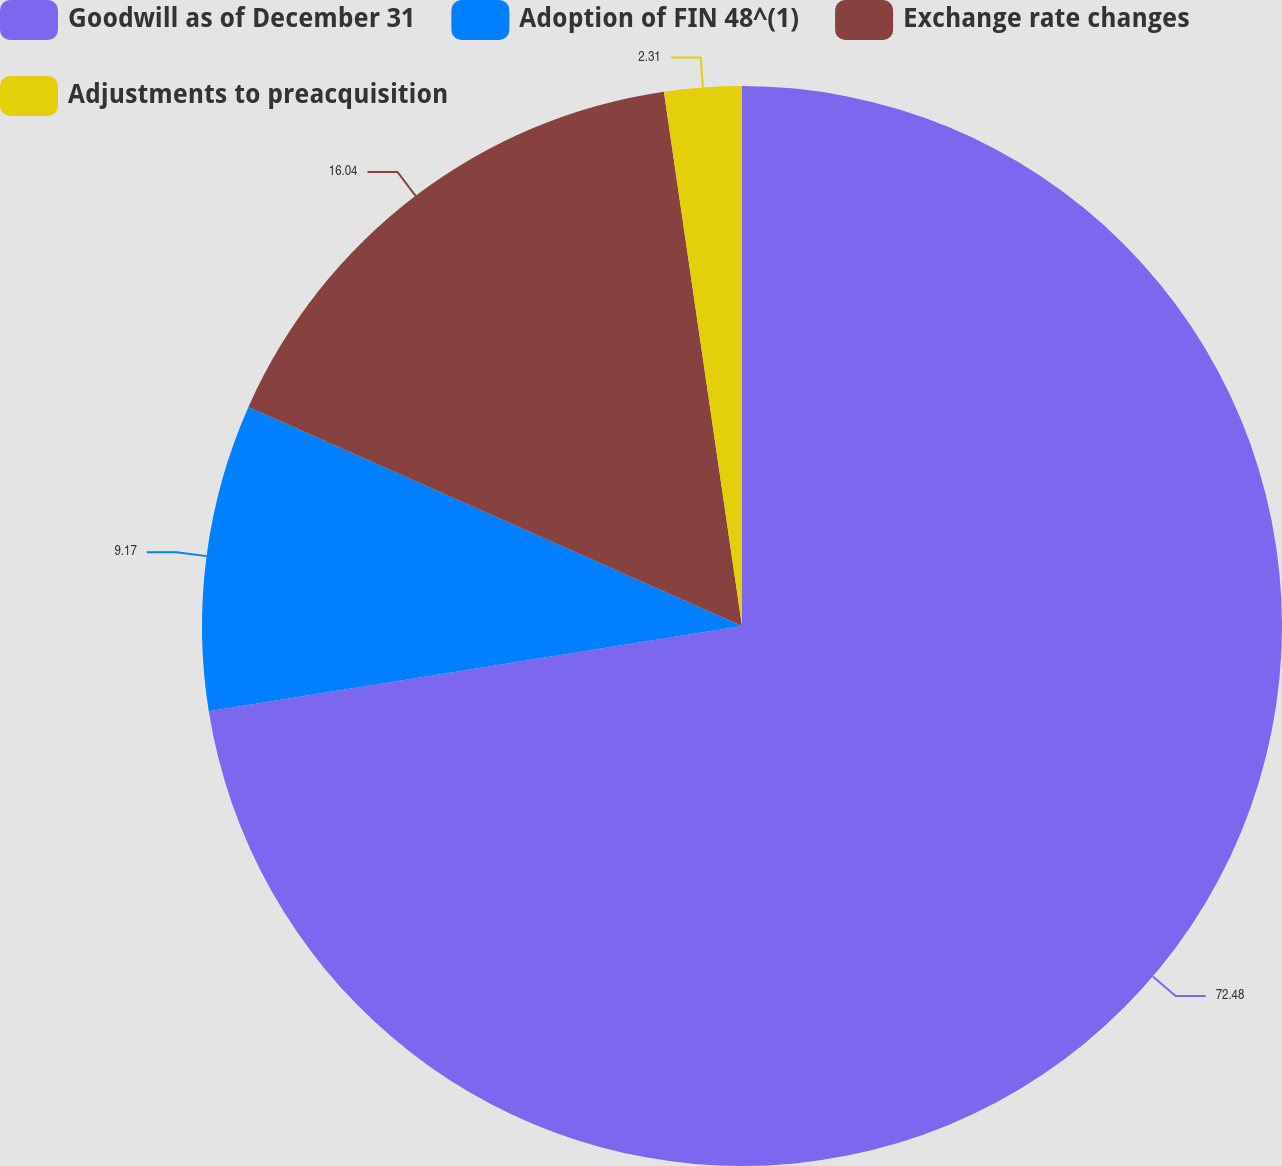<chart> <loc_0><loc_0><loc_500><loc_500><pie_chart><fcel>Goodwill as of December 31<fcel>Adoption of FIN 48^(1)<fcel>Exchange rate changes<fcel>Adjustments to preacquisition<nl><fcel>72.48%<fcel>9.17%<fcel>16.04%<fcel>2.31%<nl></chart> 